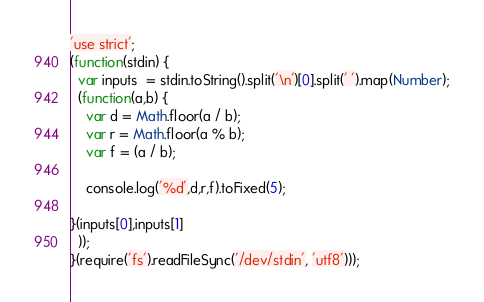<code> <loc_0><loc_0><loc_500><loc_500><_JavaScript_>'use strict';
(function(stdin) {
  var inputs  = stdin.toString().split('\n')[0].split(' ').map(Number);
  (function(a,b) {
    var d = Math.floor(a / b);
    var r = Math.floor(a % b);
    var f = (a / b);

    console.log('%d',d,r,f).toFixed(5);

}(inputs[0],inputs[1]
  )); 
}(require('fs').readFileSync('/dev/stdin', 'utf8')));</code> 